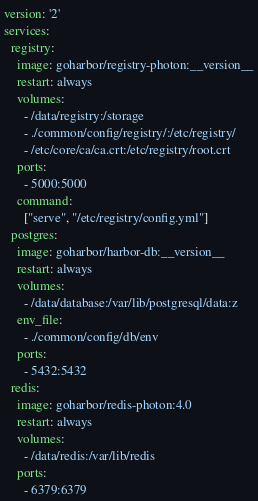Convert code to text. <code><loc_0><loc_0><loc_500><loc_500><_YAML_>version: '2'
services:
  registry:
    image: goharbor/registry-photon:__version__
    restart: always
    volumes:
      - /data/registry:/storage
      - ./common/config/registry/:/etc/registry/
      - /etc/core/ca/ca.crt:/etc/registry/root.crt
    ports:
      - 5000:5000
    command:
      ["serve", "/etc/registry/config.yml"]
  postgres:
    image: goharbor/harbor-db:__version__
    restart: always
    volumes:
      - /data/database:/var/lib/postgresql/data:z
    env_file:
      - ./common/config/db/env
    ports:
      - 5432:5432
  redis:
    image: goharbor/redis-photon:4.0
    restart: always
    volumes:
      - /data/redis:/var/lib/redis
    ports:
      - 6379:6379
</code> 